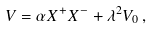<formula> <loc_0><loc_0><loc_500><loc_500>V = \alpha X ^ { + } X ^ { - } + \lambda ^ { 2 } V _ { 0 } { \, } ,</formula> 